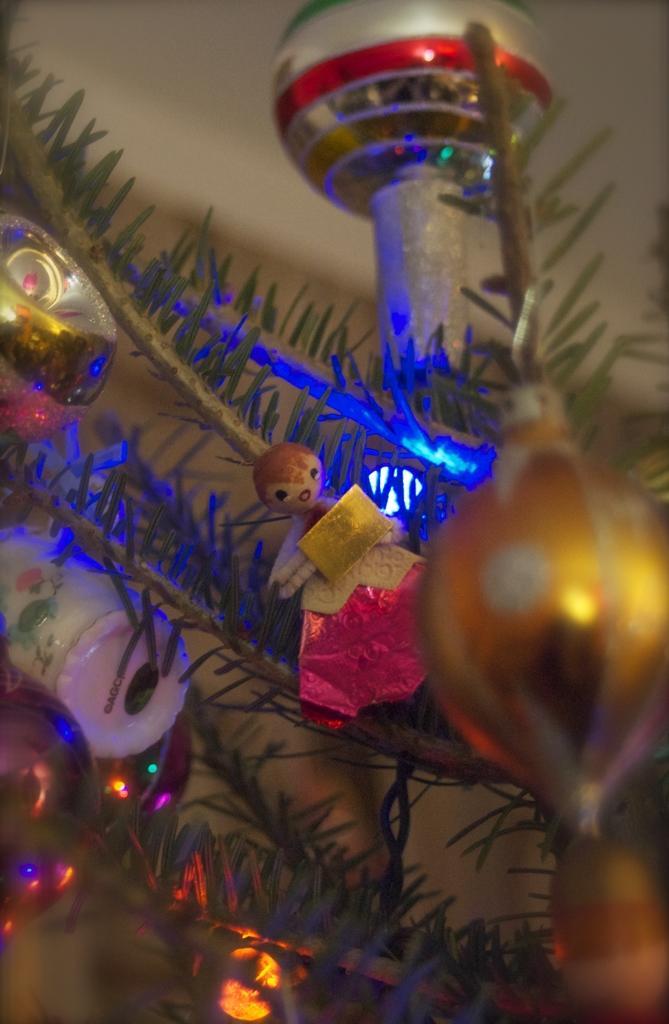Could you give a brief overview of what you see in this image? In this image I see leaves on stems and I see decoration and I see a doll over here and it is blurred in the background. 